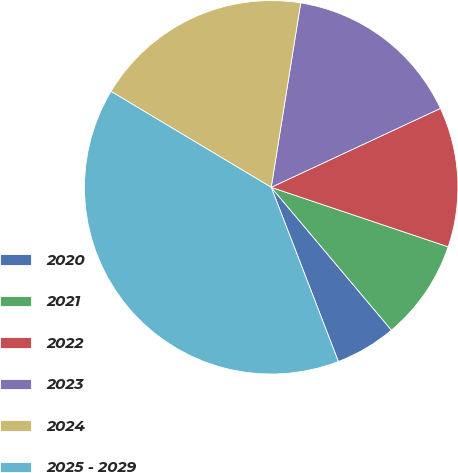<chart> <loc_0><loc_0><loc_500><loc_500><pie_chart><fcel>2020<fcel>2021<fcel>2022<fcel>2023<fcel>2024<fcel>2025 - 2029<nl><fcel>5.28%<fcel>8.7%<fcel>12.11%<fcel>15.53%<fcel>18.94%<fcel>39.44%<nl></chart> 